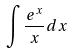Convert formula to latex. <formula><loc_0><loc_0><loc_500><loc_500>\int \frac { e ^ { x } } { x } d x</formula> 